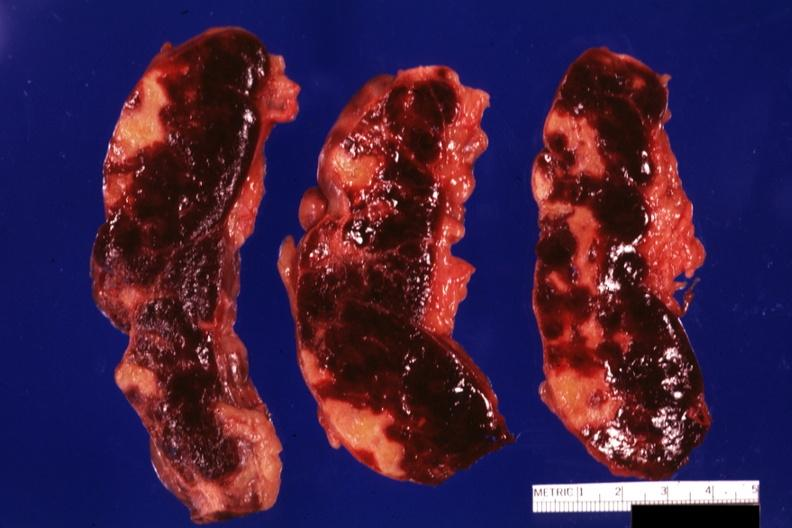s infarcts present?
Answer the question using a single word or phrase. Yes 